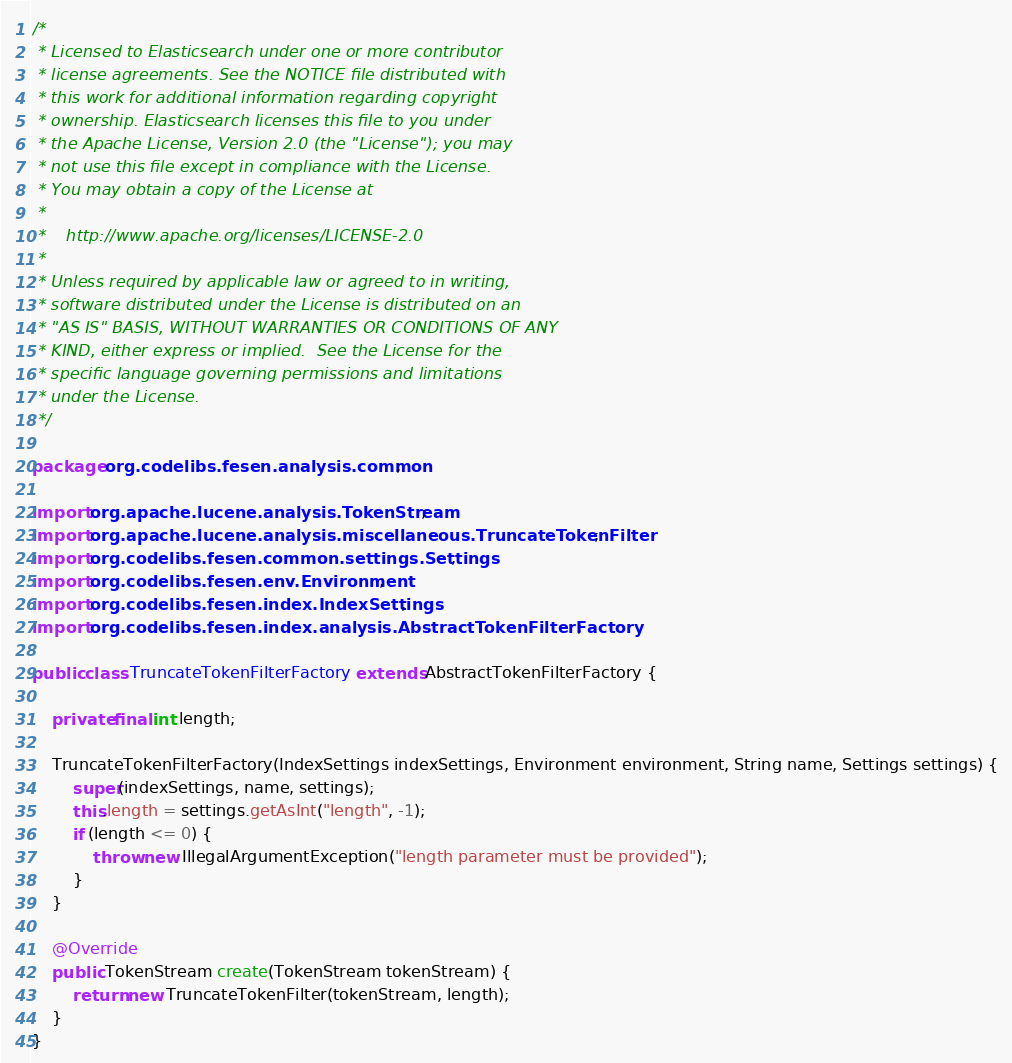Convert code to text. <code><loc_0><loc_0><loc_500><loc_500><_Java_>/*
 * Licensed to Elasticsearch under one or more contributor
 * license agreements. See the NOTICE file distributed with
 * this work for additional information regarding copyright
 * ownership. Elasticsearch licenses this file to you under
 * the Apache License, Version 2.0 (the "License"); you may
 * not use this file except in compliance with the License.
 * You may obtain a copy of the License at
 *
 *    http://www.apache.org/licenses/LICENSE-2.0
 *
 * Unless required by applicable law or agreed to in writing,
 * software distributed under the License is distributed on an
 * "AS IS" BASIS, WITHOUT WARRANTIES OR CONDITIONS OF ANY
 * KIND, either express or implied.  See the License for the
 * specific language governing permissions and limitations
 * under the License.
 */

package org.codelibs.fesen.analysis.common;

import org.apache.lucene.analysis.TokenStream;
import org.apache.lucene.analysis.miscellaneous.TruncateTokenFilter;
import org.codelibs.fesen.common.settings.Settings;
import org.codelibs.fesen.env.Environment;
import org.codelibs.fesen.index.IndexSettings;
import org.codelibs.fesen.index.analysis.AbstractTokenFilterFactory;

public class TruncateTokenFilterFactory extends AbstractTokenFilterFactory {

    private final int length;

    TruncateTokenFilterFactory(IndexSettings indexSettings, Environment environment, String name, Settings settings) {
        super(indexSettings, name, settings);
        this.length = settings.getAsInt("length", -1);
        if (length <= 0) {
            throw new IllegalArgumentException("length parameter must be provided");
        }
    }

    @Override
    public TokenStream create(TokenStream tokenStream) {
        return new TruncateTokenFilter(tokenStream, length);
    }
}
</code> 